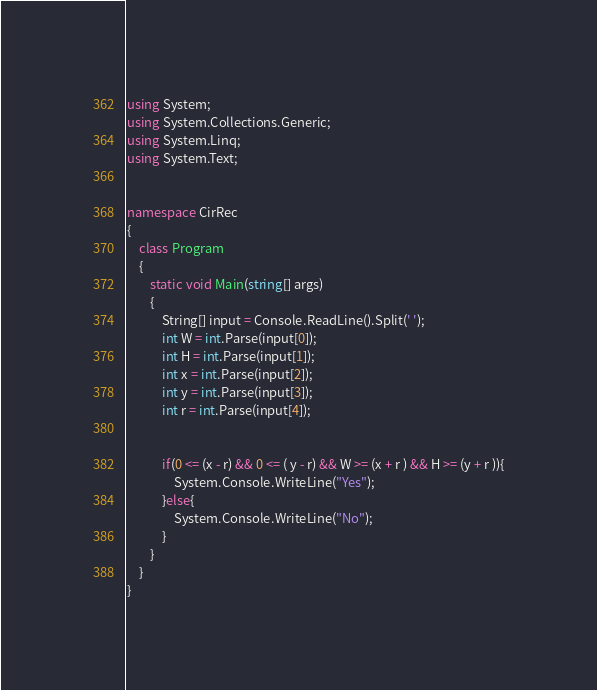Convert code to text. <code><loc_0><loc_0><loc_500><loc_500><_C#_>using System;
using System.Collections.Generic;
using System.Linq;
using System.Text;


namespace CirRec
{
    class Program
    {
        static void Main(string[] args)
        {
            String[] input = Console.ReadLine().Split(' ');
            int W = int.Parse(input[0]);
            int H = int.Parse(input[1]); 
            int x = int.Parse(input[2]);
            int y = int.Parse(input[3]);
            int r = int.Parse(input[4]); 
         

            if(0 <= (x - r) && 0 <= ( y - r) && W >= (x + r ) && H >= (y + r )){
                System.Console.WriteLine("Yes");
            }else{
                System.Console.WriteLine("No");
            }
        }
    }
}</code> 